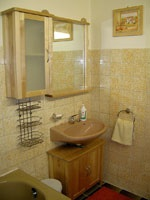Describe the objects in this image and their specific colors. I can see sink in tan, olive, and black tones, sink in tan, olive, and maroon tones, toilet in tan, gray, and black tones, and bottle in tan and olive tones in this image. 